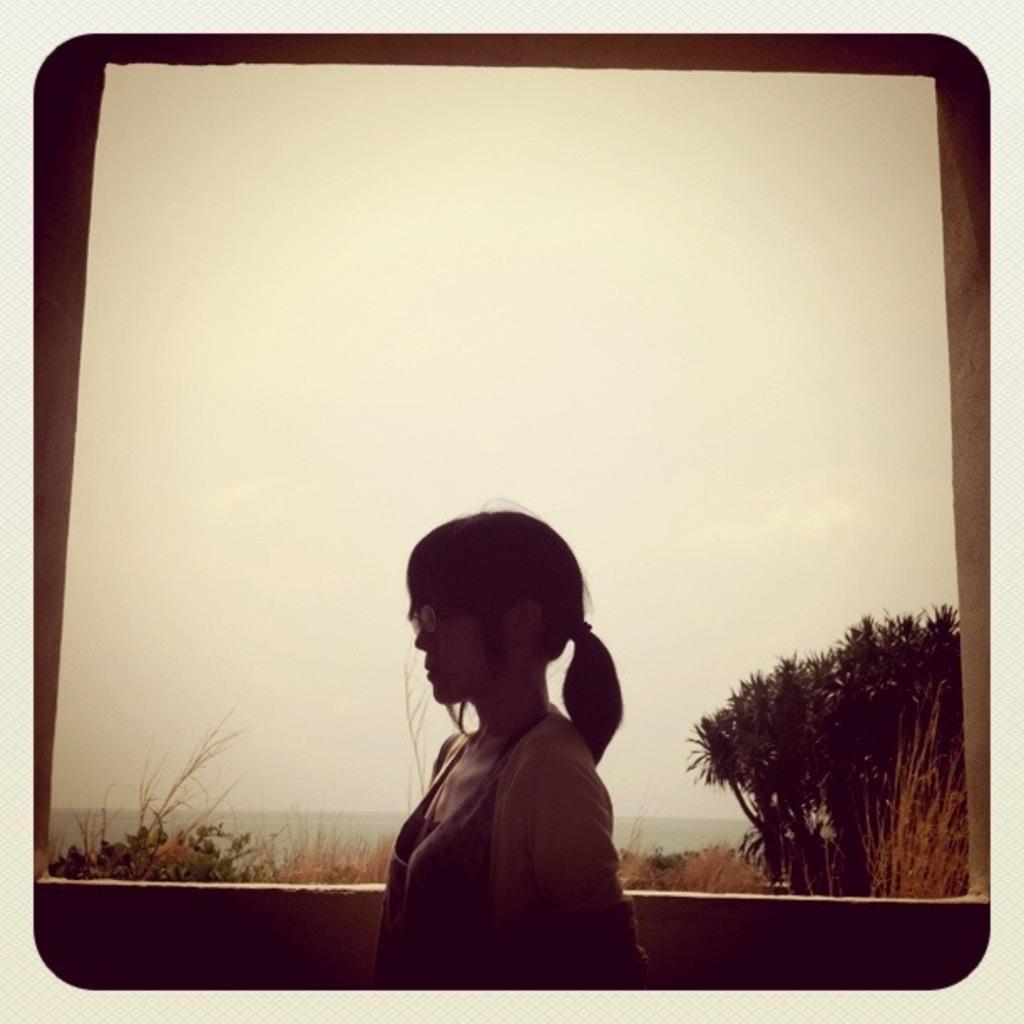Describe this image in one or two sentences. In this image, we can see a woman and wall. Background we can see plants, trees and sky. 